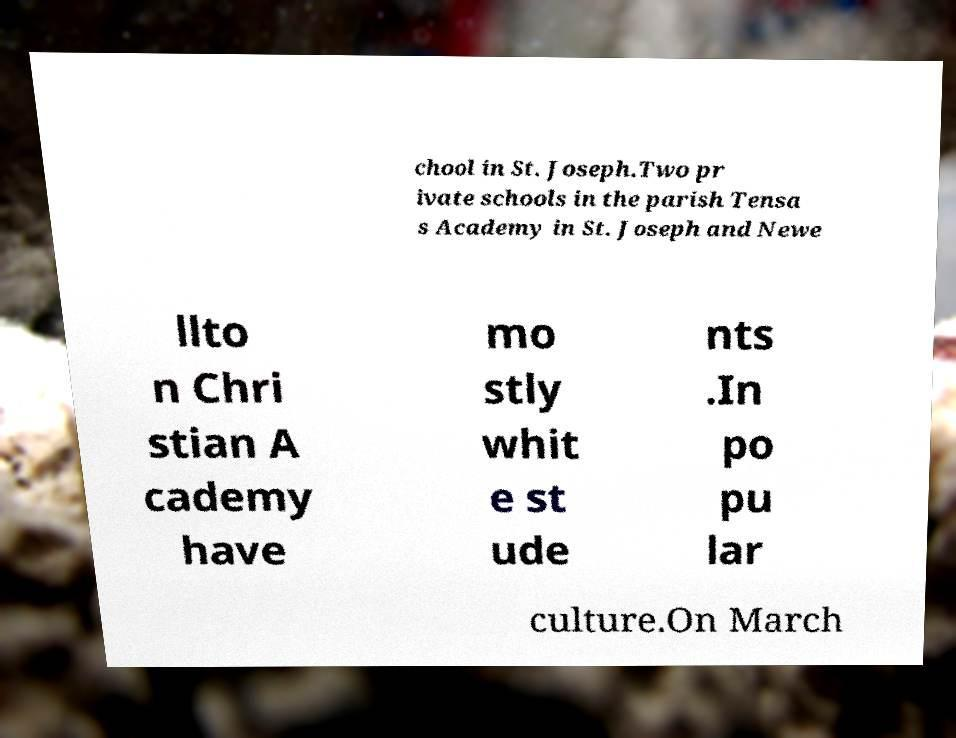I need the written content from this picture converted into text. Can you do that? chool in St. Joseph.Two pr ivate schools in the parish Tensa s Academy in St. Joseph and Newe llto n Chri stian A cademy have mo stly whit e st ude nts .In po pu lar culture.On March 